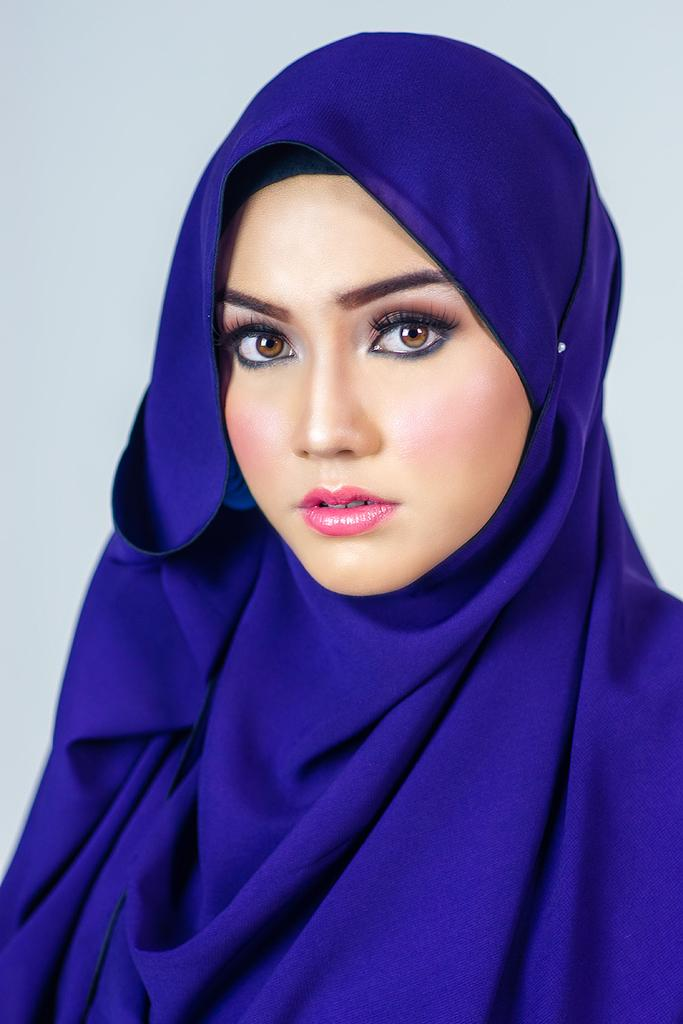Who is present in the image? There is a woman in the picture. What is the woman wearing around her neck? The woman is wearing a blue scarf. How is the woman described in the image? The woman is described as beautiful. What can be seen in the background of the picture? There is a wall in the background of the picture. Is the woman riding a bike in the image? No, there is no bike present in the image. Is the woman using a hose to water plants in the image? No, there is no hose or plants visible in the image. 